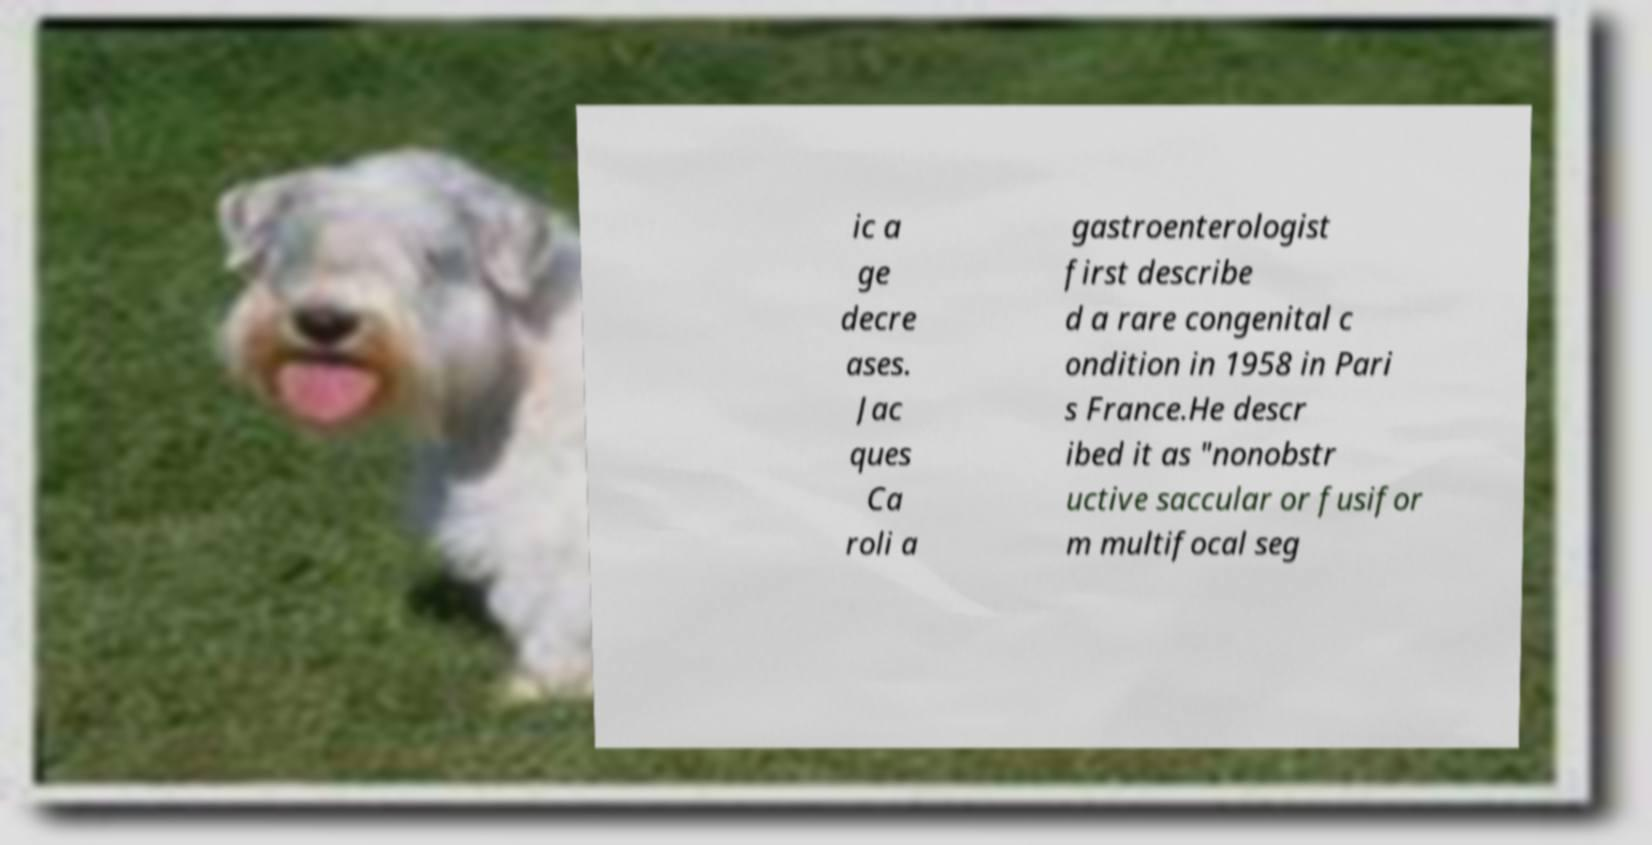Could you assist in decoding the text presented in this image and type it out clearly? ic a ge decre ases. Jac ques Ca roli a gastroenterologist first describe d a rare congenital c ondition in 1958 in Pari s France.He descr ibed it as "nonobstr uctive saccular or fusifor m multifocal seg 